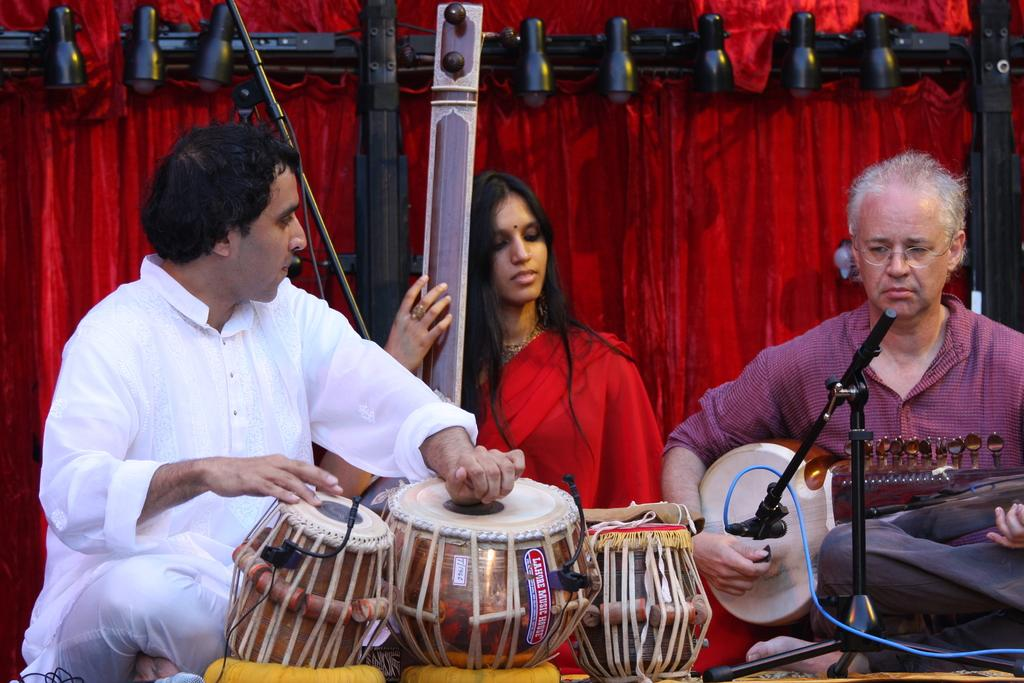How many people are in the image? There are two men and a woman in the image, making a total of three people. What are the individuals in the image doing? The individuals are sitting in the image. What are the people holding? Each person is holding a musical instrument. What can be seen in the background of the image? There are lights and curtains in the background of the image. Can you tell me how many snails are crawling on the curtains in the image? There are no snails present in the image; the background features lights and curtains without any snails. What type of horse is depicted in the image? There is no horse depicted in the image; the main subjects are three individuals holding musical instruments. 